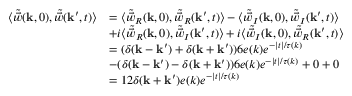Convert formula to latex. <formula><loc_0><loc_0><loc_500><loc_500>\begin{array} { r l } { \langle \tilde { \vec { w } } ( k , 0 ) , \tilde { \vec { w } } ( k ^ { \prime } , t ) \rangle } & { = \langle \tilde { \vec { w } } _ { R } ( k , 0 ) , \tilde { \vec { w } } _ { R } ( k ^ { \prime } , t ) \rangle - \langle \tilde { \vec { w } } _ { I } ( k , 0 ) , \tilde { \vec { w } } _ { I } ( k ^ { \prime } , t ) \rangle } \\ & { + i \langle \tilde { \vec { w } } _ { R } ( k , 0 ) , \tilde { \vec { w } } _ { I } ( k ^ { \prime } , t ) \rangle + i \langle \tilde { \vec { w } } _ { I } ( k , 0 ) , \tilde { \vec { w } } _ { R } ( k ^ { \prime } , t ) \rangle } \\ & { = ( \delta ( k - k ^ { \prime } ) + \delta ( k + k ^ { \prime } ) ) 6 e ( k ) e ^ { - | t | / \tau ( k ) } } \\ & { - ( \delta ( k - k ^ { \prime } ) - \delta ( k + k ^ { \prime } ) ) 6 e ( k ) e ^ { - | t | / \tau ( k ) } + 0 + 0 } \\ & { = 1 2 \delta ( k + k ^ { \prime } ) e ( k ) e ^ { - | t | / \tau ( k ) } } \end{array}</formula> 